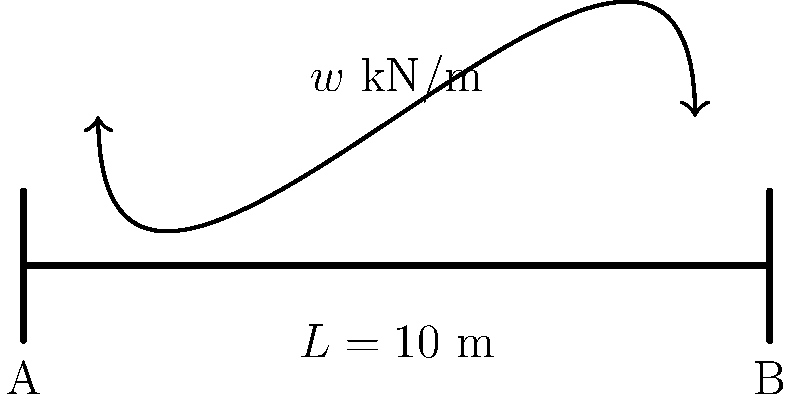In a poetic bridge of dreams spanning two literary worlds, a simple support structure bears the weight of cultural exchange. Consider a bridge with a uniform distributed load of $w$ kN/m across its entire length of $L = 10$ m. If the bridge is simply supported at both ends (A and B), determine the reaction force at support B. Let's approach this step-by-step, like crafting a verse:

1) For a simply supported beam with a uniformly distributed load, the total load is shared equally between the two supports due to symmetry.

2) The total load on the bridge is the product of the distributed load and the length of the bridge:
   Total Load = $w \times L = w \times 10$ kN

3) Since the load is uniformly distributed and the supports are at the ends, each support bears half of the total load.

4) The reaction force at support B is therefore:
   $R_B = \frac{1}{2} \times \text{Total Load} = \frac{1}{2} \times (w \times 10) = 5w$ kN

5) This result, $5w$ kN, represents the upward force at support B that balances half of the total downward force on the bridge.

Just as a poem balances rhythm and meaning, this bridge balances forces to stand strong, connecting two points like literature connects cultures.
Answer: $5w$ kN 